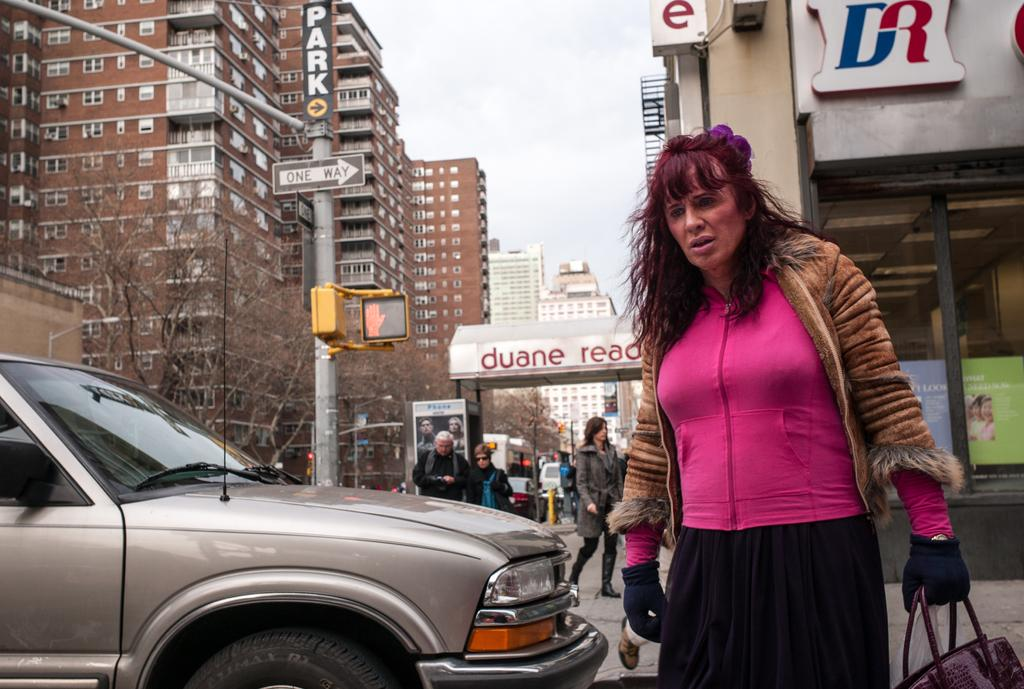What is the woman doing in the image? The woman is walking on the right side of the image. What is the woman wearing in the image? The woman is wearing a pink top. What can be seen on the left side of the image? There is a car on the left side of the image. What type of structures are visible in the image? There are buildings in the image. What is visible at the top of the image? The sky is visible at the top of the image. What type of stone is the deer holding in the image? There is no deer or stone present in the image. 